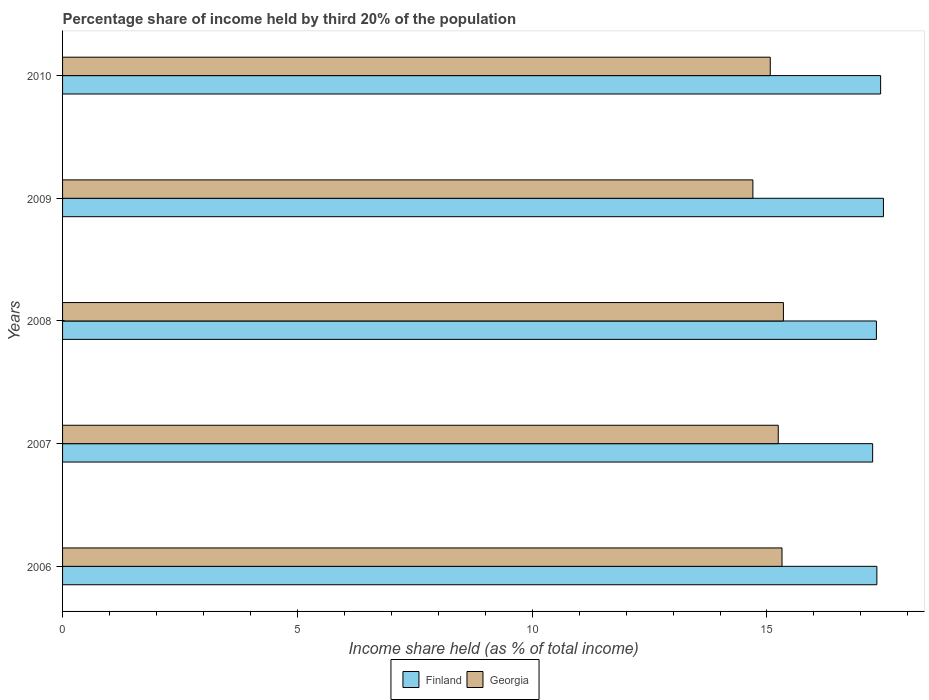Are the number of bars per tick equal to the number of legend labels?
Offer a terse response. Yes. Are the number of bars on each tick of the Y-axis equal?
Your answer should be very brief. Yes. How many bars are there on the 4th tick from the bottom?
Provide a succinct answer. 2. In how many cases, is the number of bars for a given year not equal to the number of legend labels?
Your answer should be very brief. 0. What is the share of income held by third 20% of the population in Finland in 2006?
Your answer should be very brief. 17.34. Across all years, what is the maximum share of income held by third 20% of the population in Georgia?
Provide a succinct answer. 15.35. Across all years, what is the minimum share of income held by third 20% of the population in Finland?
Provide a succinct answer. 17.25. In which year was the share of income held by third 20% of the population in Finland maximum?
Provide a short and direct response. 2009. In which year was the share of income held by third 20% of the population in Georgia minimum?
Provide a short and direct response. 2009. What is the total share of income held by third 20% of the population in Georgia in the graph?
Offer a very short reply. 75.68. What is the difference between the share of income held by third 20% of the population in Finland in 2006 and that in 2007?
Provide a succinct answer. 0.09. What is the difference between the share of income held by third 20% of the population in Georgia in 2010 and the share of income held by third 20% of the population in Finland in 2008?
Ensure brevity in your answer.  -2.26. What is the average share of income held by third 20% of the population in Georgia per year?
Make the answer very short. 15.14. In the year 2007, what is the difference between the share of income held by third 20% of the population in Georgia and share of income held by third 20% of the population in Finland?
Your answer should be very brief. -2.01. In how many years, is the share of income held by third 20% of the population in Finland greater than 15 %?
Your answer should be compact. 5. What is the ratio of the share of income held by third 20% of the population in Georgia in 2007 to that in 2009?
Provide a short and direct response. 1.04. Is the difference between the share of income held by third 20% of the population in Georgia in 2006 and 2008 greater than the difference between the share of income held by third 20% of the population in Finland in 2006 and 2008?
Provide a short and direct response. No. What is the difference between the highest and the second highest share of income held by third 20% of the population in Georgia?
Your response must be concise. 0.03. What is the difference between the highest and the lowest share of income held by third 20% of the population in Georgia?
Ensure brevity in your answer.  0.65. In how many years, is the share of income held by third 20% of the population in Georgia greater than the average share of income held by third 20% of the population in Georgia taken over all years?
Provide a short and direct response. 3. Is the sum of the share of income held by third 20% of the population in Finland in 2007 and 2010 greater than the maximum share of income held by third 20% of the population in Georgia across all years?
Offer a very short reply. Yes. What does the 2nd bar from the bottom in 2007 represents?
Ensure brevity in your answer.  Georgia. How many years are there in the graph?
Provide a short and direct response. 5. Are the values on the major ticks of X-axis written in scientific E-notation?
Your answer should be compact. No. Does the graph contain grids?
Provide a succinct answer. No. Where does the legend appear in the graph?
Keep it short and to the point. Bottom center. How many legend labels are there?
Keep it short and to the point. 2. What is the title of the graph?
Your answer should be very brief. Percentage share of income held by third 20% of the population. Does "Singapore" appear as one of the legend labels in the graph?
Give a very brief answer. No. What is the label or title of the X-axis?
Offer a very short reply. Income share held (as % of total income). What is the label or title of the Y-axis?
Your answer should be very brief. Years. What is the Income share held (as % of total income) of Finland in 2006?
Keep it short and to the point. 17.34. What is the Income share held (as % of total income) of Georgia in 2006?
Your answer should be compact. 15.32. What is the Income share held (as % of total income) in Finland in 2007?
Offer a terse response. 17.25. What is the Income share held (as % of total income) of Georgia in 2007?
Ensure brevity in your answer.  15.24. What is the Income share held (as % of total income) of Finland in 2008?
Your answer should be very brief. 17.33. What is the Income share held (as % of total income) of Georgia in 2008?
Ensure brevity in your answer.  15.35. What is the Income share held (as % of total income) of Finland in 2009?
Your response must be concise. 17.48. What is the Income share held (as % of total income) in Finland in 2010?
Your response must be concise. 17.42. What is the Income share held (as % of total income) in Georgia in 2010?
Your answer should be very brief. 15.07. Across all years, what is the maximum Income share held (as % of total income) of Finland?
Give a very brief answer. 17.48. Across all years, what is the maximum Income share held (as % of total income) of Georgia?
Offer a terse response. 15.35. Across all years, what is the minimum Income share held (as % of total income) in Finland?
Keep it short and to the point. 17.25. What is the total Income share held (as % of total income) in Finland in the graph?
Your answer should be compact. 86.82. What is the total Income share held (as % of total income) in Georgia in the graph?
Offer a very short reply. 75.68. What is the difference between the Income share held (as % of total income) in Finland in 2006 and that in 2007?
Provide a short and direct response. 0.09. What is the difference between the Income share held (as % of total income) of Georgia in 2006 and that in 2007?
Your response must be concise. 0.08. What is the difference between the Income share held (as % of total income) of Georgia in 2006 and that in 2008?
Offer a very short reply. -0.03. What is the difference between the Income share held (as % of total income) in Finland in 2006 and that in 2009?
Offer a terse response. -0.14. What is the difference between the Income share held (as % of total income) in Georgia in 2006 and that in 2009?
Keep it short and to the point. 0.62. What is the difference between the Income share held (as % of total income) of Finland in 2006 and that in 2010?
Ensure brevity in your answer.  -0.08. What is the difference between the Income share held (as % of total income) of Finland in 2007 and that in 2008?
Keep it short and to the point. -0.08. What is the difference between the Income share held (as % of total income) of Georgia in 2007 and that in 2008?
Provide a short and direct response. -0.11. What is the difference between the Income share held (as % of total income) in Finland in 2007 and that in 2009?
Keep it short and to the point. -0.23. What is the difference between the Income share held (as % of total income) of Georgia in 2007 and that in 2009?
Provide a short and direct response. 0.54. What is the difference between the Income share held (as % of total income) in Finland in 2007 and that in 2010?
Keep it short and to the point. -0.17. What is the difference between the Income share held (as % of total income) of Georgia in 2007 and that in 2010?
Offer a terse response. 0.17. What is the difference between the Income share held (as % of total income) of Georgia in 2008 and that in 2009?
Offer a very short reply. 0.65. What is the difference between the Income share held (as % of total income) of Finland in 2008 and that in 2010?
Give a very brief answer. -0.09. What is the difference between the Income share held (as % of total income) of Georgia in 2008 and that in 2010?
Make the answer very short. 0.28. What is the difference between the Income share held (as % of total income) in Georgia in 2009 and that in 2010?
Ensure brevity in your answer.  -0.37. What is the difference between the Income share held (as % of total income) in Finland in 2006 and the Income share held (as % of total income) in Georgia in 2008?
Your response must be concise. 1.99. What is the difference between the Income share held (as % of total income) of Finland in 2006 and the Income share held (as % of total income) of Georgia in 2009?
Your answer should be very brief. 2.64. What is the difference between the Income share held (as % of total income) of Finland in 2006 and the Income share held (as % of total income) of Georgia in 2010?
Provide a succinct answer. 2.27. What is the difference between the Income share held (as % of total income) of Finland in 2007 and the Income share held (as % of total income) of Georgia in 2009?
Offer a terse response. 2.55. What is the difference between the Income share held (as % of total income) in Finland in 2007 and the Income share held (as % of total income) in Georgia in 2010?
Your answer should be very brief. 2.18. What is the difference between the Income share held (as % of total income) of Finland in 2008 and the Income share held (as % of total income) of Georgia in 2009?
Your answer should be very brief. 2.63. What is the difference between the Income share held (as % of total income) of Finland in 2008 and the Income share held (as % of total income) of Georgia in 2010?
Provide a succinct answer. 2.26. What is the difference between the Income share held (as % of total income) in Finland in 2009 and the Income share held (as % of total income) in Georgia in 2010?
Offer a terse response. 2.41. What is the average Income share held (as % of total income) of Finland per year?
Provide a short and direct response. 17.36. What is the average Income share held (as % of total income) in Georgia per year?
Your response must be concise. 15.14. In the year 2006, what is the difference between the Income share held (as % of total income) in Finland and Income share held (as % of total income) in Georgia?
Your answer should be compact. 2.02. In the year 2007, what is the difference between the Income share held (as % of total income) of Finland and Income share held (as % of total income) of Georgia?
Make the answer very short. 2.01. In the year 2008, what is the difference between the Income share held (as % of total income) in Finland and Income share held (as % of total income) in Georgia?
Offer a terse response. 1.98. In the year 2009, what is the difference between the Income share held (as % of total income) of Finland and Income share held (as % of total income) of Georgia?
Offer a terse response. 2.78. In the year 2010, what is the difference between the Income share held (as % of total income) in Finland and Income share held (as % of total income) in Georgia?
Offer a very short reply. 2.35. What is the ratio of the Income share held (as % of total income) of Georgia in 2006 to that in 2008?
Provide a short and direct response. 1. What is the ratio of the Income share held (as % of total income) of Georgia in 2006 to that in 2009?
Your answer should be very brief. 1.04. What is the ratio of the Income share held (as % of total income) in Georgia in 2006 to that in 2010?
Provide a succinct answer. 1.02. What is the ratio of the Income share held (as % of total income) of Georgia in 2007 to that in 2009?
Your answer should be compact. 1.04. What is the ratio of the Income share held (as % of total income) of Finland in 2007 to that in 2010?
Provide a short and direct response. 0.99. What is the ratio of the Income share held (as % of total income) in Georgia in 2007 to that in 2010?
Keep it short and to the point. 1.01. What is the ratio of the Income share held (as % of total income) of Georgia in 2008 to that in 2009?
Offer a very short reply. 1.04. What is the ratio of the Income share held (as % of total income) in Georgia in 2008 to that in 2010?
Provide a short and direct response. 1.02. What is the ratio of the Income share held (as % of total income) in Finland in 2009 to that in 2010?
Make the answer very short. 1. What is the ratio of the Income share held (as % of total income) in Georgia in 2009 to that in 2010?
Keep it short and to the point. 0.98. What is the difference between the highest and the second highest Income share held (as % of total income) in Georgia?
Make the answer very short. 0.03. What is the difference between the highest and the lowest Income share held (as % of total income) in Finland?
Provide a short and direct response. 0.23. What is the difference between the highest and the lowest Income share held (as % of total income) in Georgia?
Your response must be concise. 0.65. 